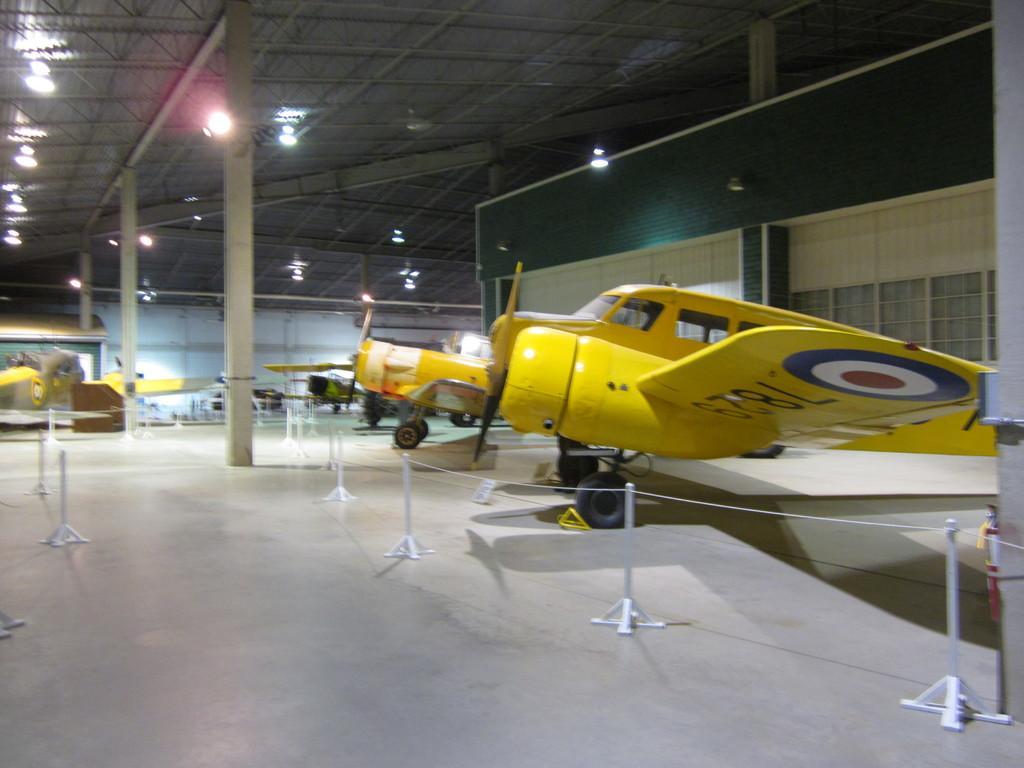What type of vehicles are present in the image? There are aircrafts in the image. What structures can be seen in the image? There are poles, a rope, lights, a rooftop, and walls in the image. What type of smoke can be seen coming from the aircrafts in the image? There is no smoke visible in the image; only aircrafts, poles, a rope, lights, a rooftop, and walls are present. What scientific experiments are being conducted on the rooftop in the image? There is no indication of any scientific experiments being conducted in the image; it only shows aircrafts, poles, a rope, lights, a rooftop, and walls. 